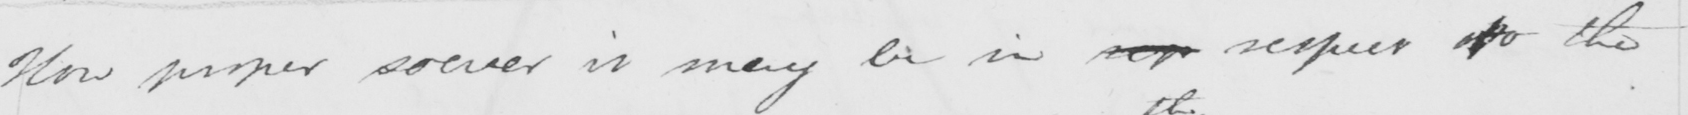What is written in this line of handwriting? How proper soever it may be in sep respect of the 